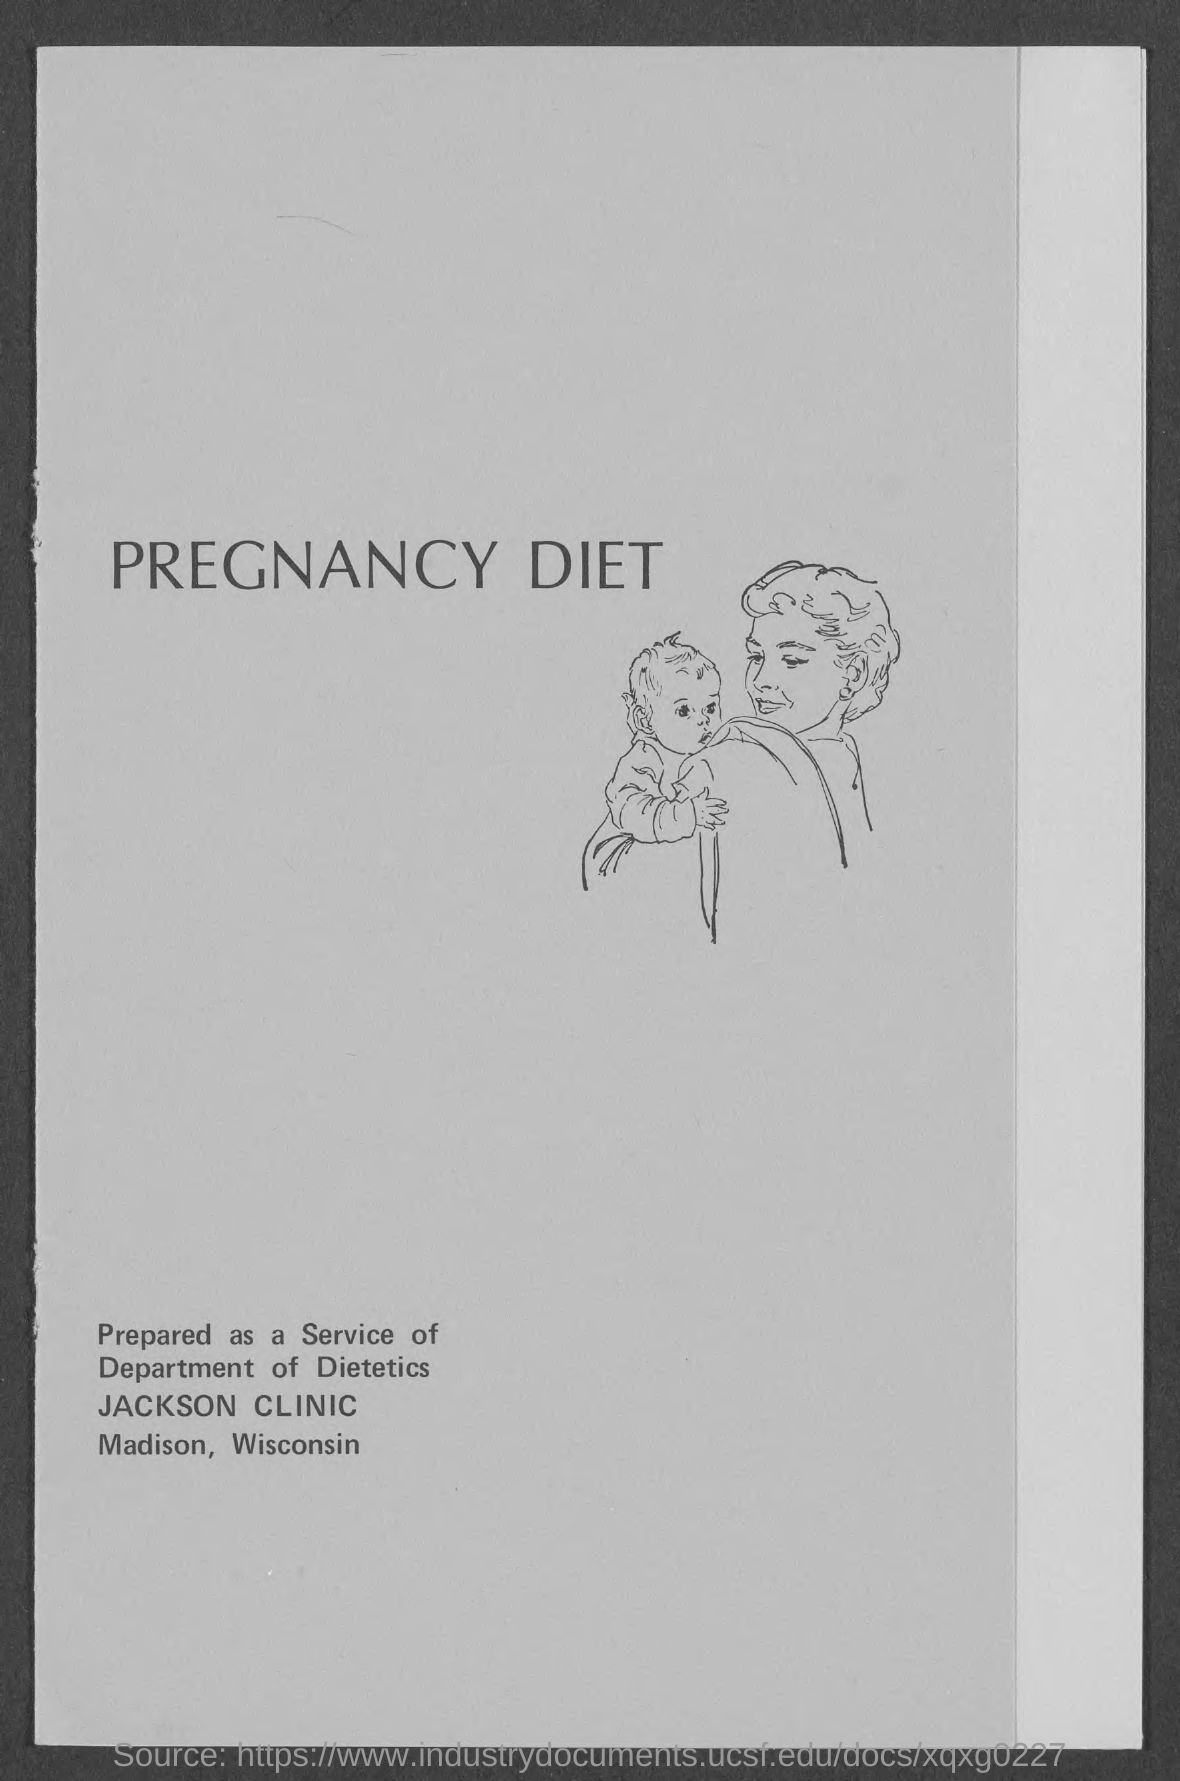Specify some key components in this picture. The title of this diet is the pregnancy diet. 